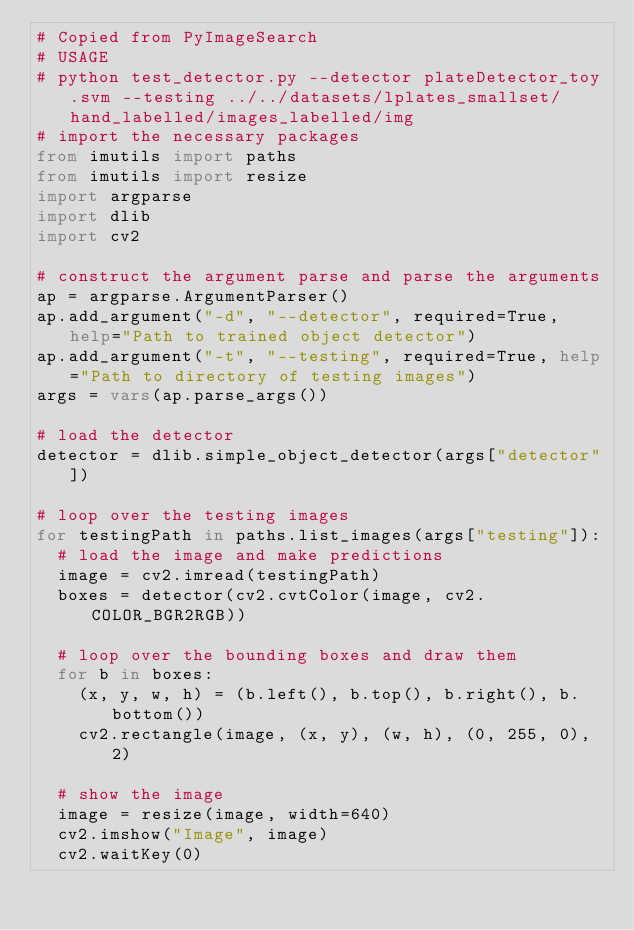Convert code to text. <code><loc_0><loc_0><loc_500><loc_500><_Python_># Copied from PyImageSearch
# USAGE
# python test_detector.py --detector plateDetector_toy.svm --testing ../../datasets/lplates_smallset/hand_labelled/images_labelled/img
# import the necessary packages
from imutils import paths
from imutils import resize
import argparse
import dlib
import cv2

# construct the argument parse and parse the arguments
ap = argparse.ArgumentParser()
ap.add_argument("-d", "--detector", required=True, help="Path to trained object detector")
ap.add_argument("-t", "--testing", required=True, help="Path to directory of testing images")
args = vars(ap.parse_args())

# load the detector
detector = dlib.simple_object_detector(args["detector"])

# loop over the testing images
for testingPath in paths.list_images(args["testing"]):
  # load the image and make predictions
  image = cv2.imread(testingPath)
  boxes = detector(cv2.cvtColor(image, cv2.COLOR_BGR2RGB))

  # loop over the bounding boxes and draw them
  for b in boxes:
    (x, y, w, h) = (b.left(), b.top(), b.right(), b.bottom())
    cv2.rectangle(image, (x, y), (w, h), (0, 255, 0), 2)

  # show the image
  image = resize(image, width=640)
  cv2.imshow("Image", image)
  cv2.waitKey(0)
</code> 